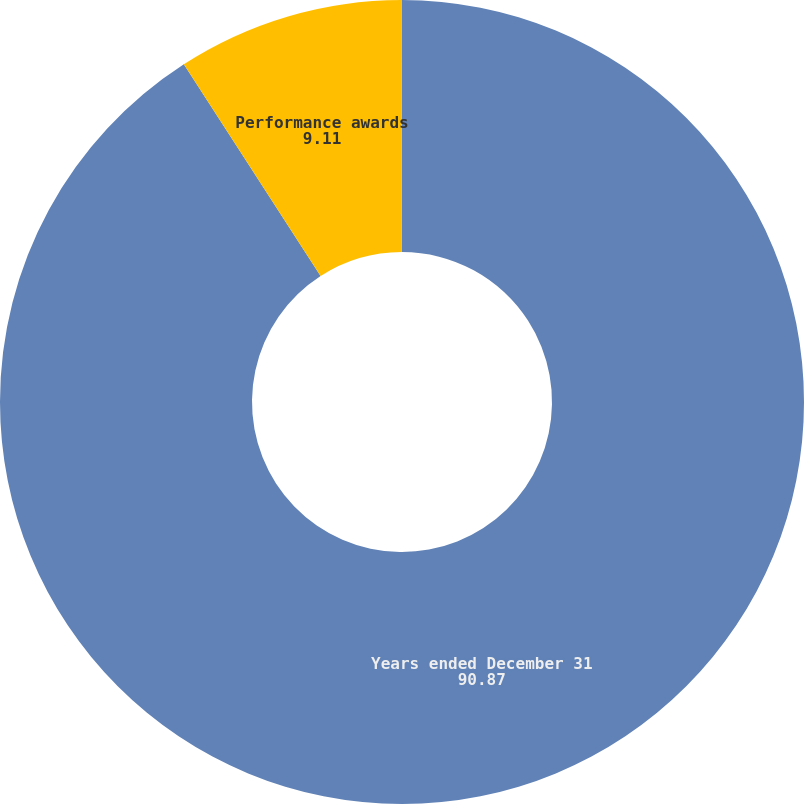Convert chart to OTSL. <chart><loc_0><loc_0><loc_500><loc_500><pie_chart><fcel>Years ended December 31<fcel>Performance awards<fcel>Performance-based restricted<nl><fcel>90.87%<fcel>9.11%<fcel>0.02%<nl></chart> 